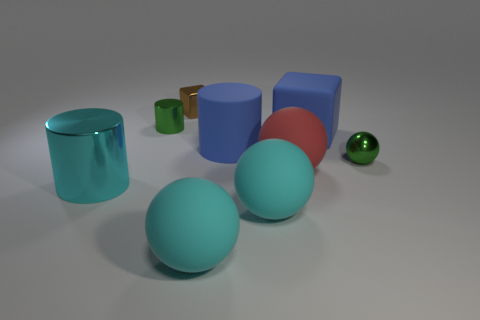There is a green thing that is behind the tiny green shiny ball; is it the same size as the matte ball behind the cyan shiny thing?
Give a very brief answer. No. How many other things are there of the same material as the small brown block?
Ensure brevity in your answer.  3. How many shiny things are blue cubes or tiny things?
Ensure brevity in your answer.  3. Is the number of tiny purple metallic things less than the number of large matte cylinders?
Offer a terse response. Yes. Does the rubber cylinder have the same size as the shiny cylinder that is behind the big metal object?
Ensure brevity in your answer.  No. Is there anything else that is the same shape as the small brown shiny object?
Provide a short and direct response. Yes. What is the size of the green cylinder?
Provide a succinct answer. Small. Are there fewer green shiny cylinders that are right of the big cyan shiny cylinder than small metal balls?
Ensure brevity in your answer.  No. Is the size of the blue rubber cylinder the same as the cyan metal object?
Ensure brevity in your answer.  Yes. Is there anything else that has the same size as the metal block?
Offer a terse response. Yes. 